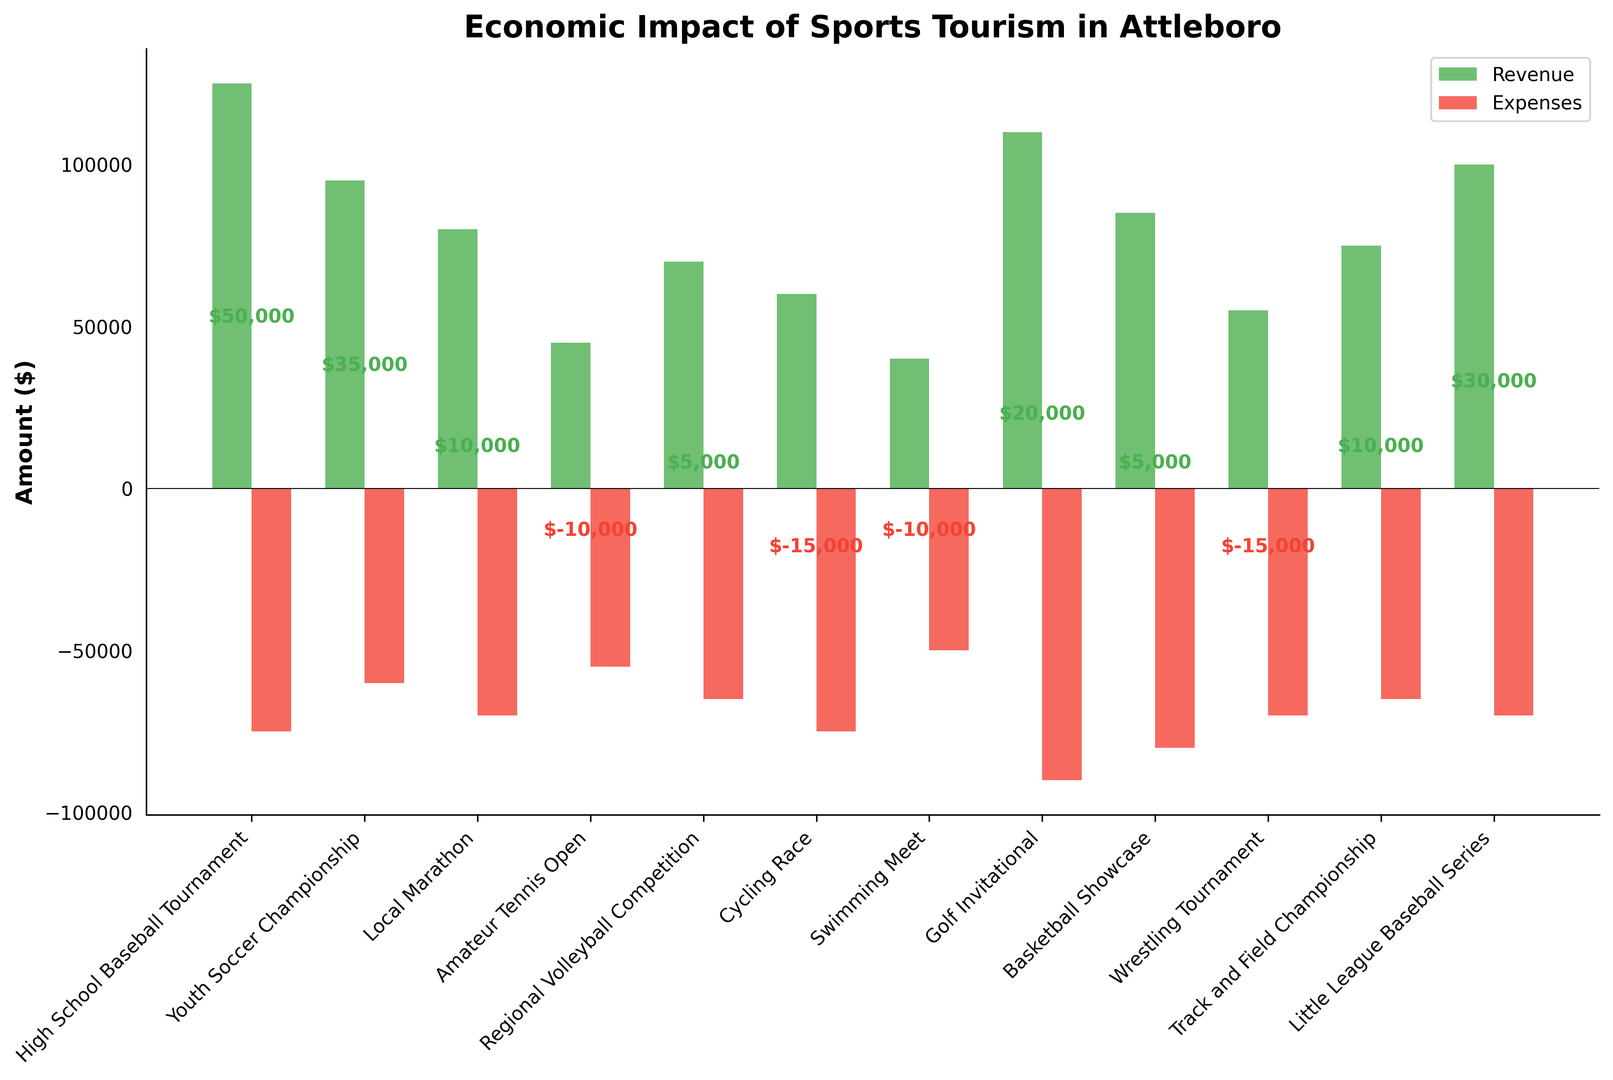What is the total net impact of the sports events that generate a positive net impact? Sum up the net impacts of events with positive values: $50,000 (High School Baseball Tournament) + $35,000 (Youth Soccer Championship) + $10,000 (Local Marathon) + $5,000 (Regional Volleyball Competition) + $20,000 (Golf Invitational) + $5,000 (Basketball Showcase) + $10,000 (Track and Field Championship) + $30,000 (Little League Baseball Series) = $165,000
Answer: $165,000 Which sports event has the highest revenue? Look at the green bars (revenue) and identify the tallest one, which represents the highest value. The High School Baseball Tournament has the tallest green bar with $125,000.
Answer: High School Baseball Tournament How many events have their expenses higher than their revenue? Compare the red (expenses) and green (revenue) bars for each event. The events with higher expenses than revenue are: Amateur Tennis Open, Cycling Race, Swimming Meet, Wrestling Tournament. This makes a total of 4 events.
Answer: 4 What is the average revenue of the high-revenue sports events (events with revenues above $80,000)? Identify high-revenue events: High School Baseball Tournament ($125,000), Youth Soccer Championship ($95,000), Golf Invitational ($110,000), Basketball Showcase ($85,000), Little League Baseball Series ($100,000). Average revenue = (125,000 + 95,000 + 110,000 + 85,000 + 100,000) / 5 = 515,000 / 5 = $103,000.
Answer: $103,000 Which sports event has the most significant negative net impact, and what is that value? Identify the event with the most significant negative net impact by looking at the lowest label positioned below the x-axis: Wrestling Tournament with a net impact of -$15,000.
Answer: Wrestling Tournament, -$15,000 What is the combined total of revenue and expenses for the Little League Baseball Series? Add the revenue ($100,000) and expenses ($70,000) for the Little League Baseball Series: $100,000 + $70,000 = $170,000
Answer: $170,000 Compare the net impact of the Youth Soccer Championship and the Golf Invitational. Which is higher and by how much? Net impact of Youth Soccer Championship ($35,000) and Golf Invitational ($20,000). Calculate the difference: $35,000 - $20,000 = $15,000; Youth Soccer Championship has a higher net impact.
Answer: Youth Soccer Championship, $15,000 What are the respective heights of the revenue and expenses bars for the High School Baseball Tournament in a ratio? Revenue bar height for High School Baseball Tournament is $125,000 and expenses bar height is $75,000. The ratio is 125,000:75,000 which simplifies to 5:3.
Answer: 5:3 